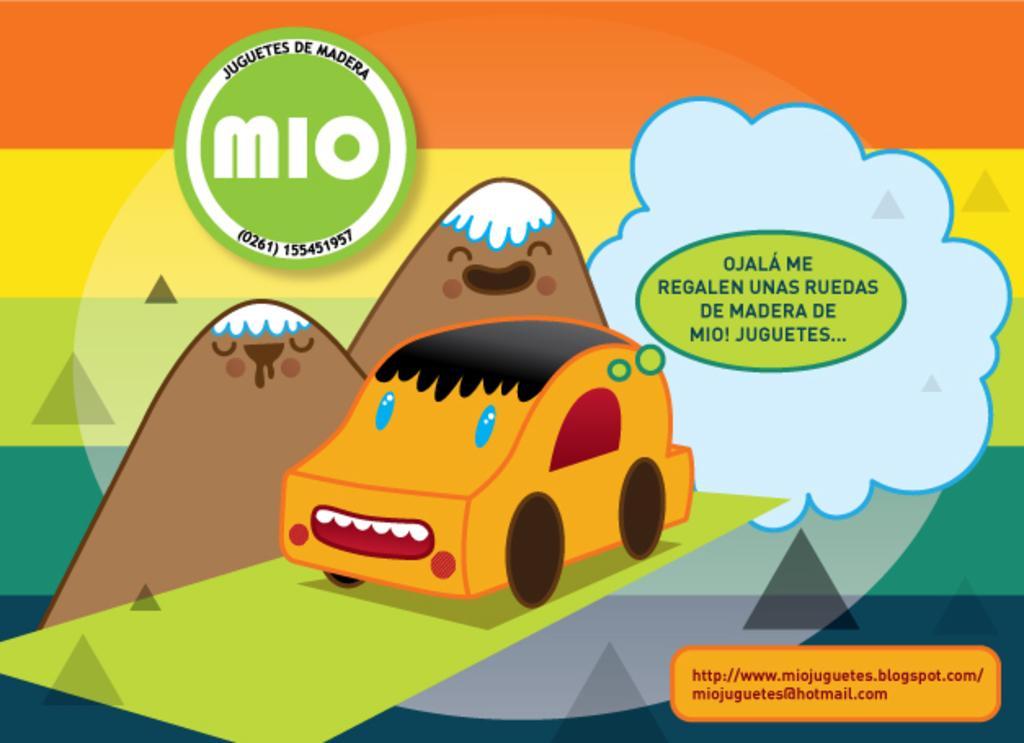How would you summarize this image in a sentence or two? In the image we can see there is a cartoon poster in which there is a car, there are mountains and there is a cloud. 